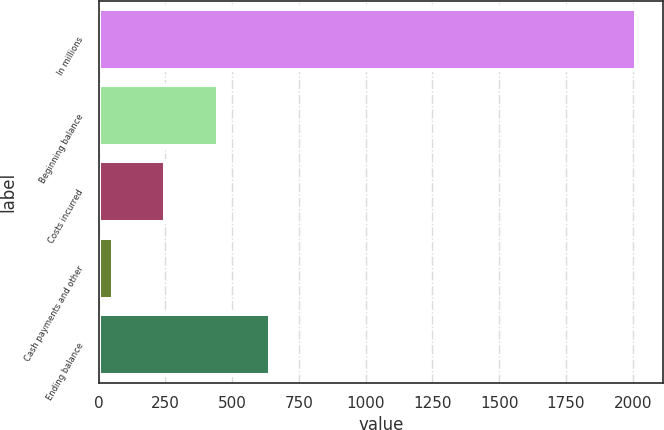Convert chart. <chart><loc_0><loc_0><loc_500><loc_500><bar_chart><fcel>In millions<fcel>Beginning balance<fcel>Costs incurred<fcel>Cash payments and other<fcel>Ending balance<nl><fcel>2014<fcel>446.08<fcel>250.09<fcel>54.1<fcel>642.07<nl></chart> 